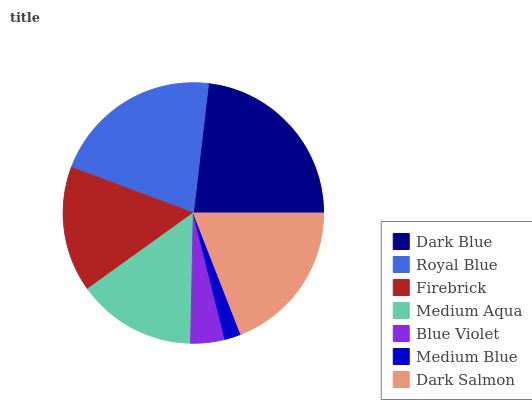Is Medium Blue the minimum?
Answer yes or no. Yes. Is Dark Blue the maximum?
Answer yes or no. Yes. Is Royal Blue the minimum?
Answer yes or no. No. Is Royal Blue the maximum?
Answer yes or no. No. Is Dark Blue greater than Royal Blue?
Answer yes or no. Yes. Is Royal Blue less than Dark Blue?
Answer yes or no. Yes. Is Royal Blue greater than Dark Blue?
Answer yes or no. No. Is Dark Blue less than Royal Blue?
Answer yes or no. No. Is Firebrick the high median?
Answer yes or no. Yes. Is Firebrick the low median?
Answer yes or no. Yes. Is Royal Blue the high median?
Answer yes or no. No. Is Medium Blue the low median?
Answer yes or no. No. 